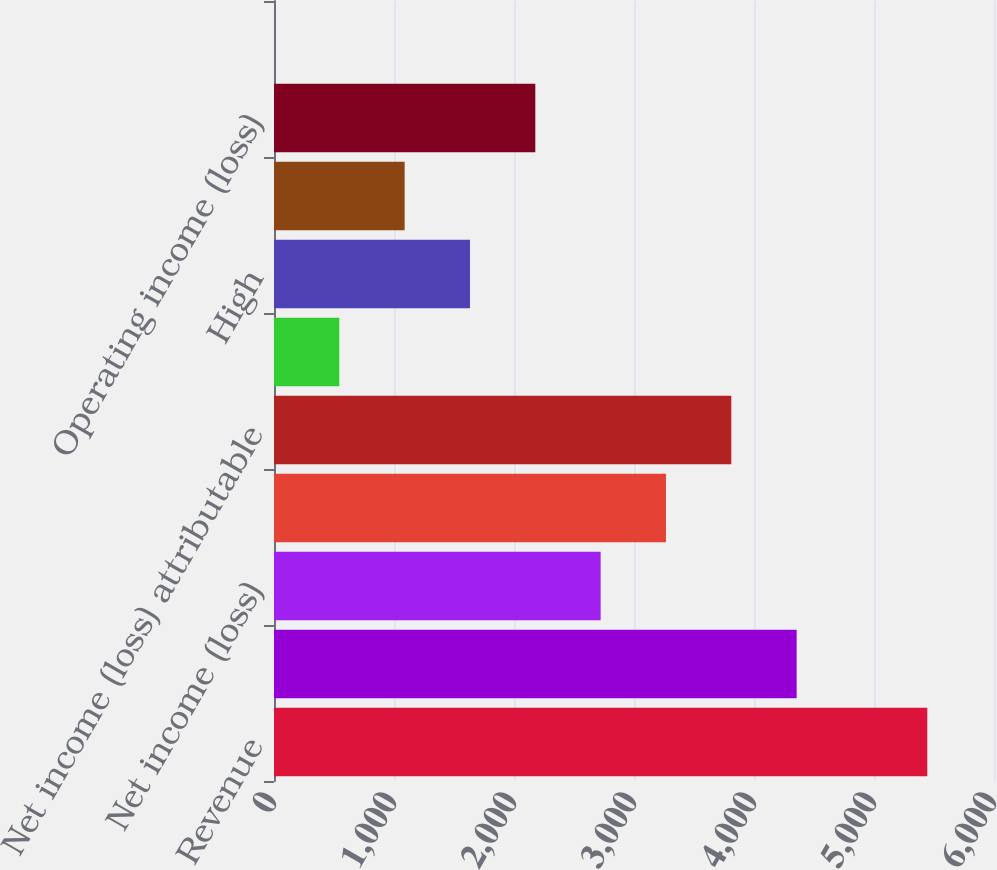<chart> <loc_0><loc_0><loc_500><loc_500><bar_chart><fcel>Revenue<fcel>Operating income<fcel>Net income (loss)<fcel>Income (loss) from continuing<fcel>Net income (loss) attributable<fcel>Cash dividends paid per share<fcel>High<fcel>Low<fcel>Operating income (loss)<fcel>Basic and diluted net income<nl><fcel>5444<fcel>4355.21<fcel>2722.01<fcel>3266.41<fcel>3810.81<fcel>544.41<fcel>1633.21<fcel>1088.81<fcel>2177.61<fcel>0.01<nl></chart> 